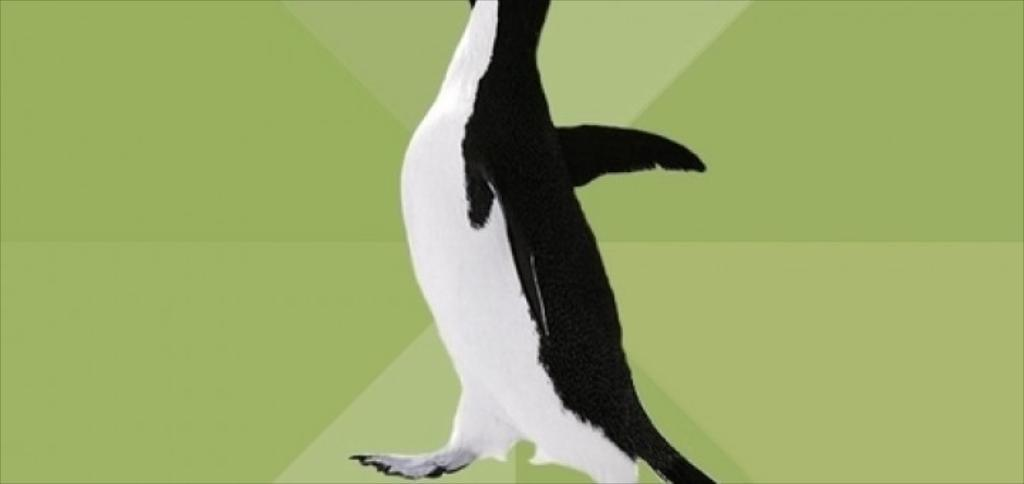What type of artwork is the image? The image is a painting. What subject is depicted in the painting? The painting depicts a penguin. What type of comfort can be seen in the painting? There is no reference to comfort in the painting, as it features a penguin. Is there an airplane visible in the painting? No, there is no airplane present in the painting; it only depicts a penguin. What news event is being reported in the painting? There is no news event being reported in the painting, as it only depicts a penguin. 